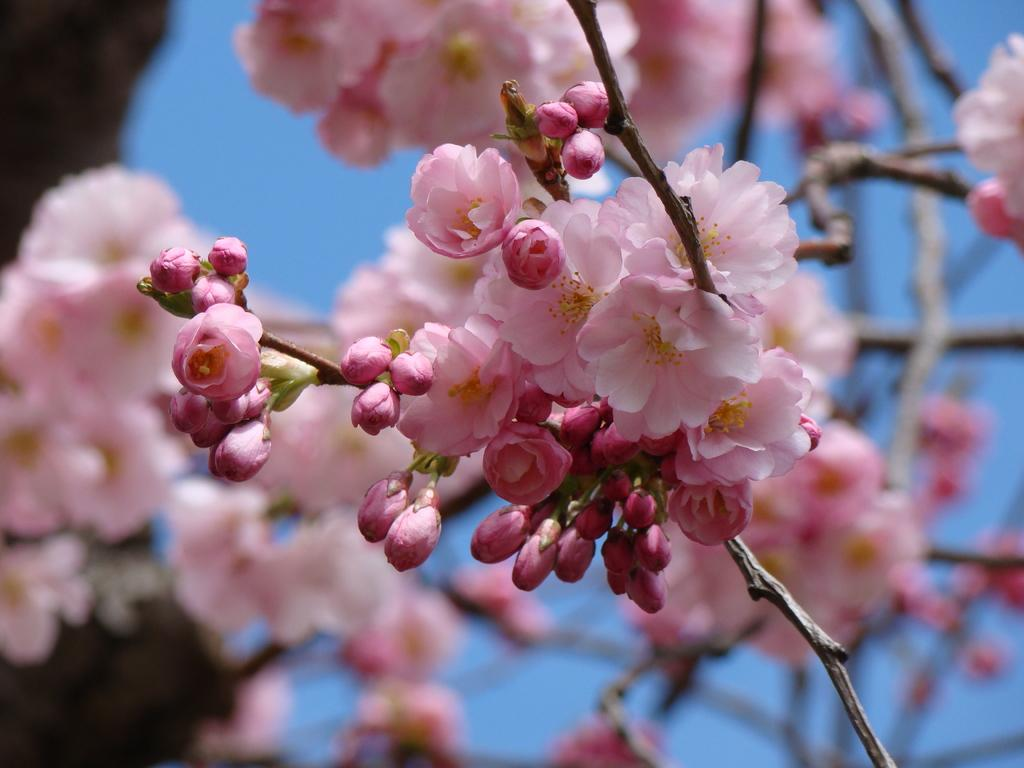What type of living organisms can be seen in the image? There are flowers in the image. What type of train can be seen passing by the flowers in the image? There is no train present in the image; it only features flowers. What type of chair can be seen near the flowers in the image? There is no chair present in the image; it only features flowers. 